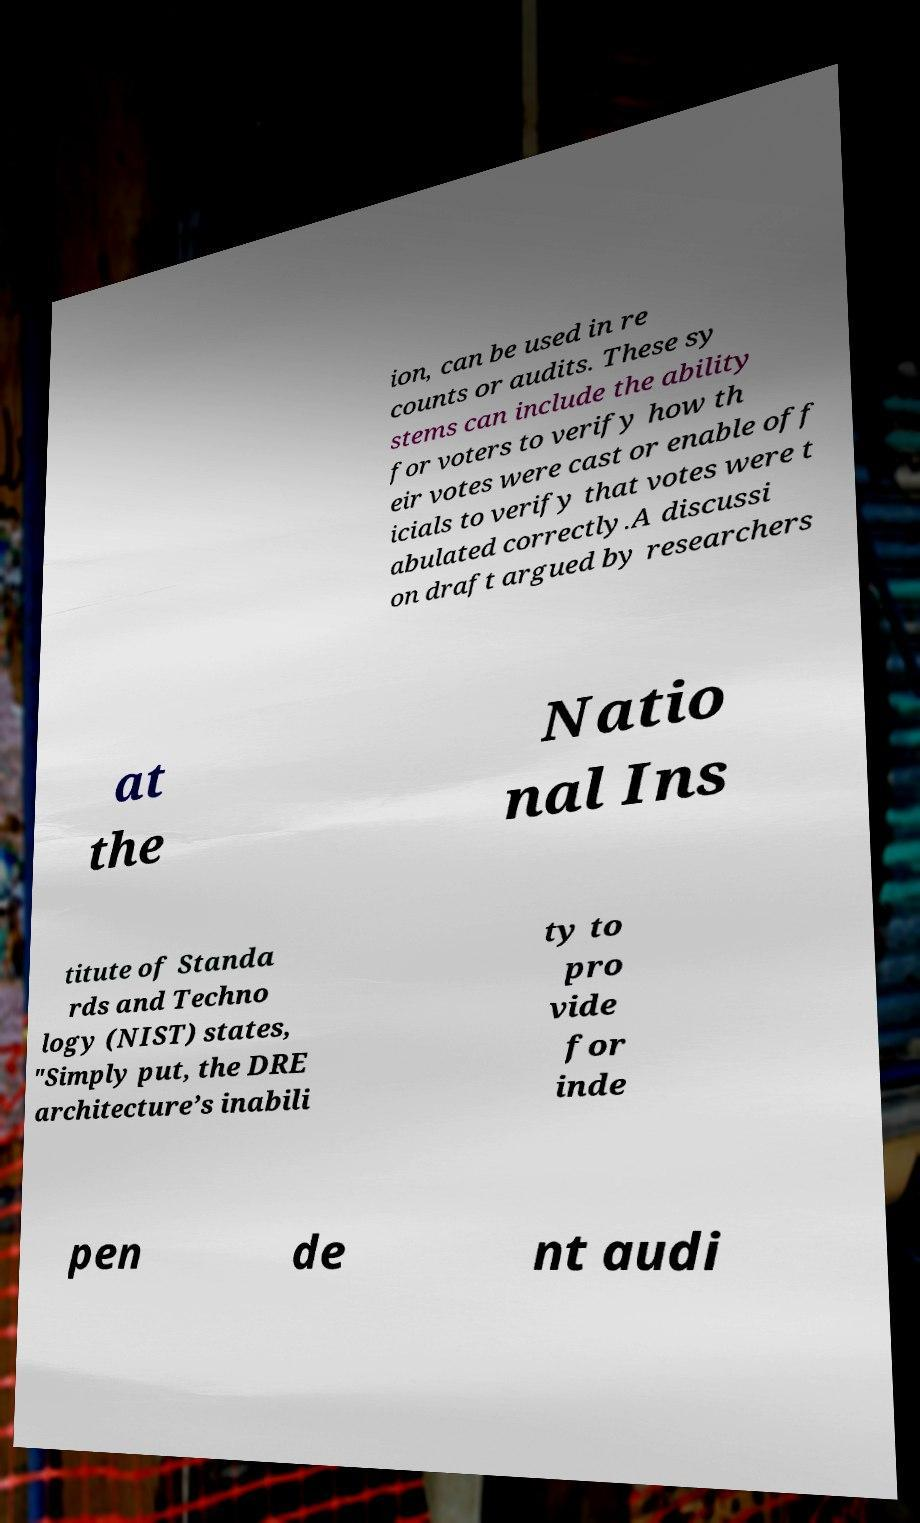Can you read and provide the text displayed in the image?This photo seems to have some interesting text. Can you extract and type it out for me? ion, can be used in re counts or audits. These sy stems can include the ability for voters to verify how th eir votes were cast or enable off icials to verify that votes were t abulated correctly.A discussi on draft argued by researchers at the Natio nal Ins titute of Standa rds and Techno logy (NIST) states, "Simply put, the DRE architecture’s inabili ty to pro vide for inde pen de nt audi 